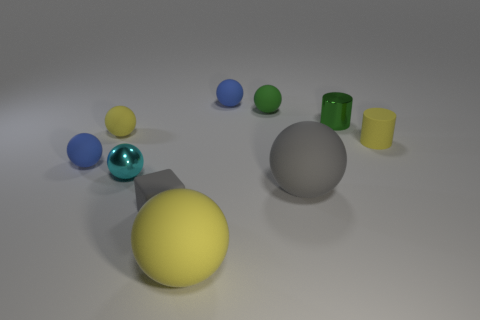Subtract all small cyan balls. How many balls are left? 6 Subtract 5 spheres. How many spheres are left? 2 Subtract all green spheres. How many spheres are left? 6 Subtract all blue balls. Subtract all yellow cylinders. How many balls are left? 5 Subtract all blocks. How many objects are left? 9 Subtract 0 red cubes. How many objects are left? 10 Subtract all big green rubber cylinders. Subtract all cyan things. How many objects are left? 9 Add 8 green spheres. How many green spheres are left? 9 Add 1 big yellow matte things. How many big yellow matte things exist? 2 